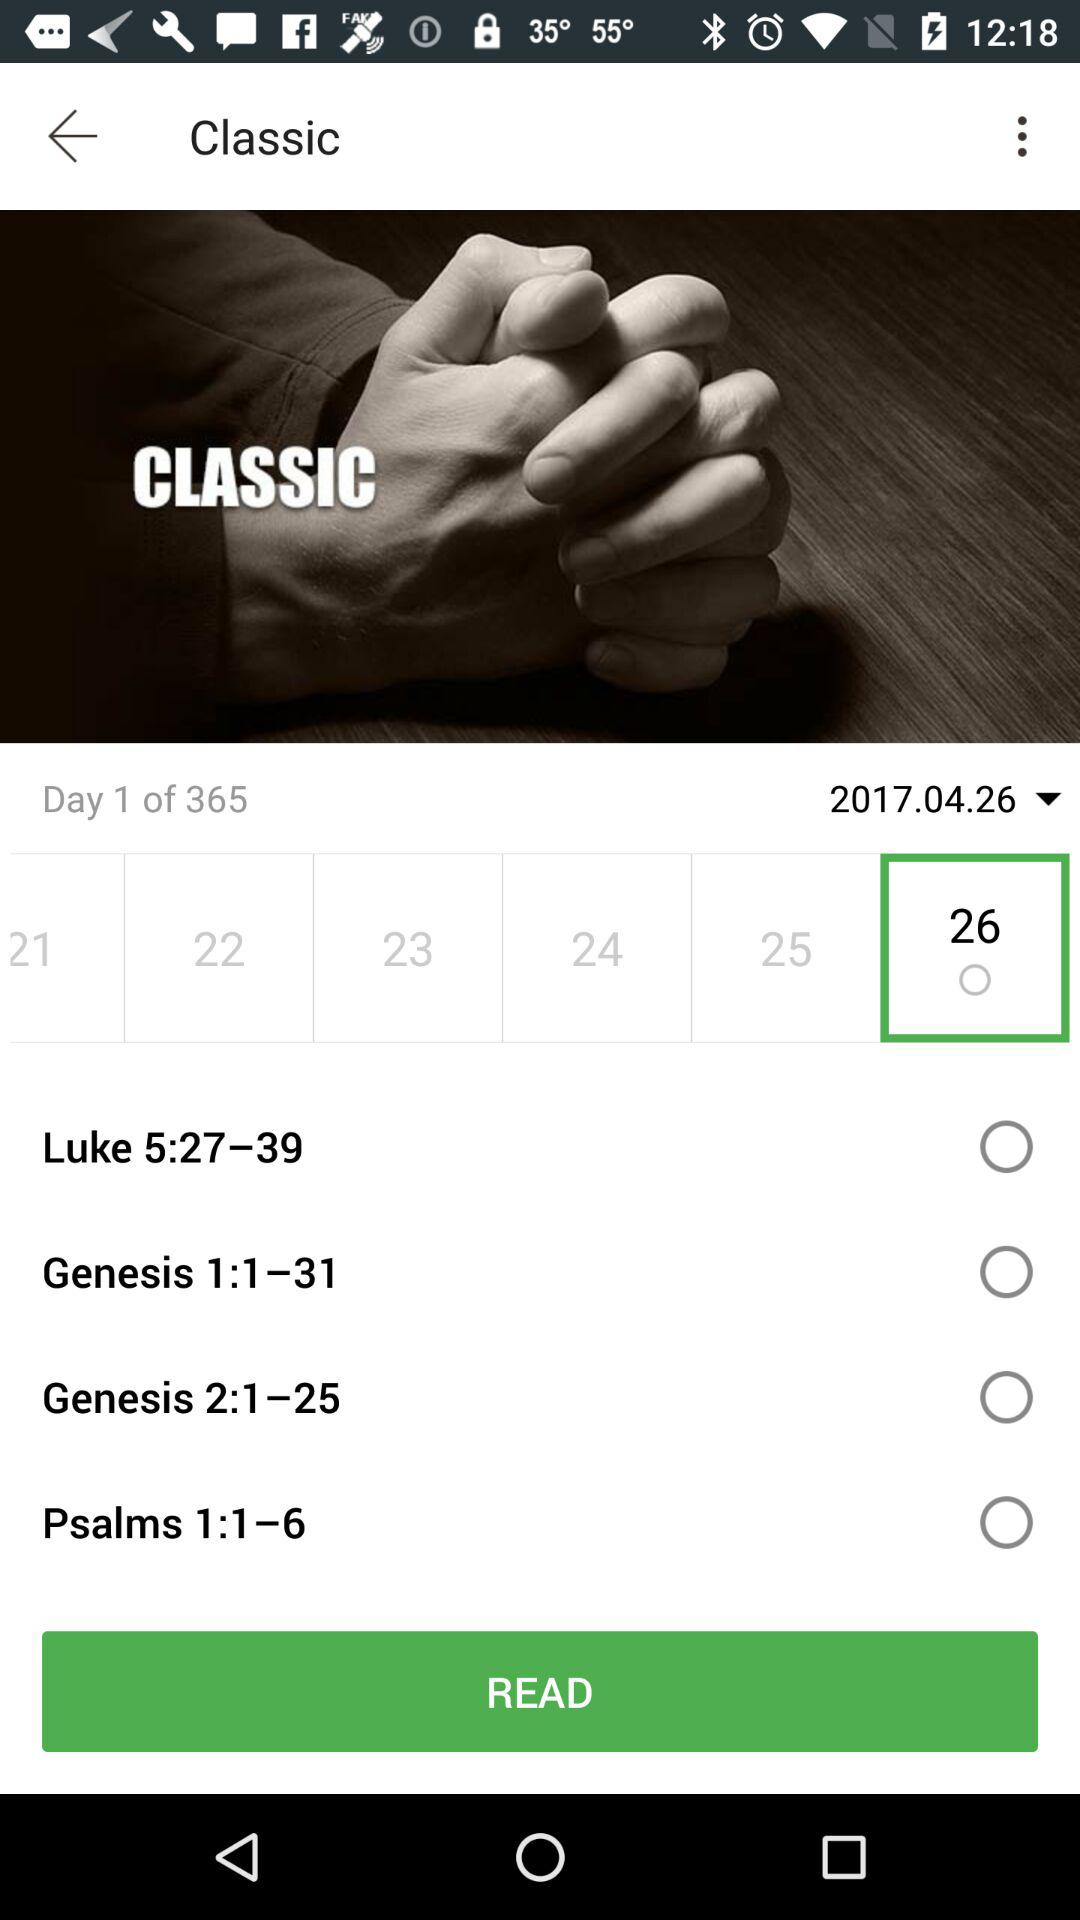How many more days are left in the year than the day displayed?
Answer the question using a single word or phrase. 364 